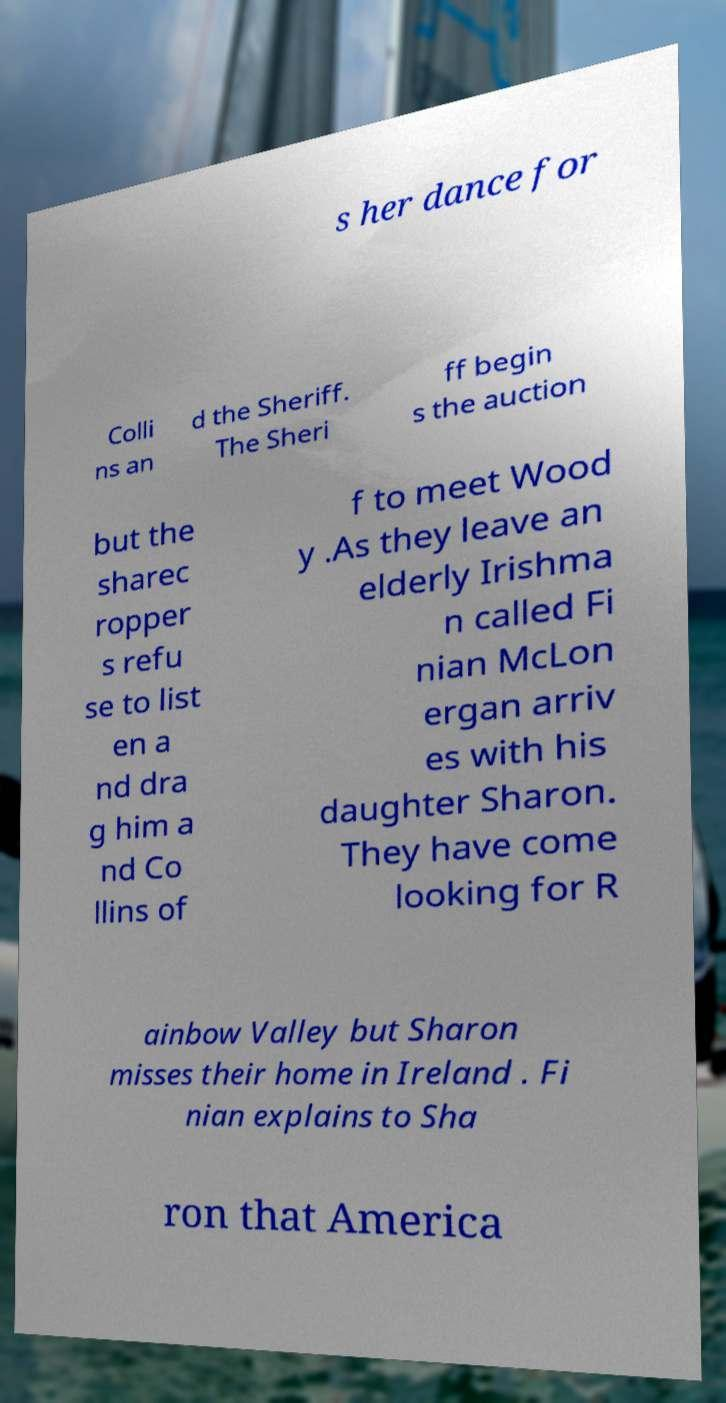I need the written content from this picture converted into text. Can you do that? s her dance for Colli ns an d the Sheriff. The Sheri ff begin s the auction but the sharec ropper s refu se to list en a nd dra g him a nd Co llins of f to meet Wood y .As they leave an elderly Irishma n called Fi nian McLon ergan arriv es with his daughter Sharon. They have come looking for R ainbow Valley but Sharon misses their home in Ireland . Fi nian explains to Sha ron that America 